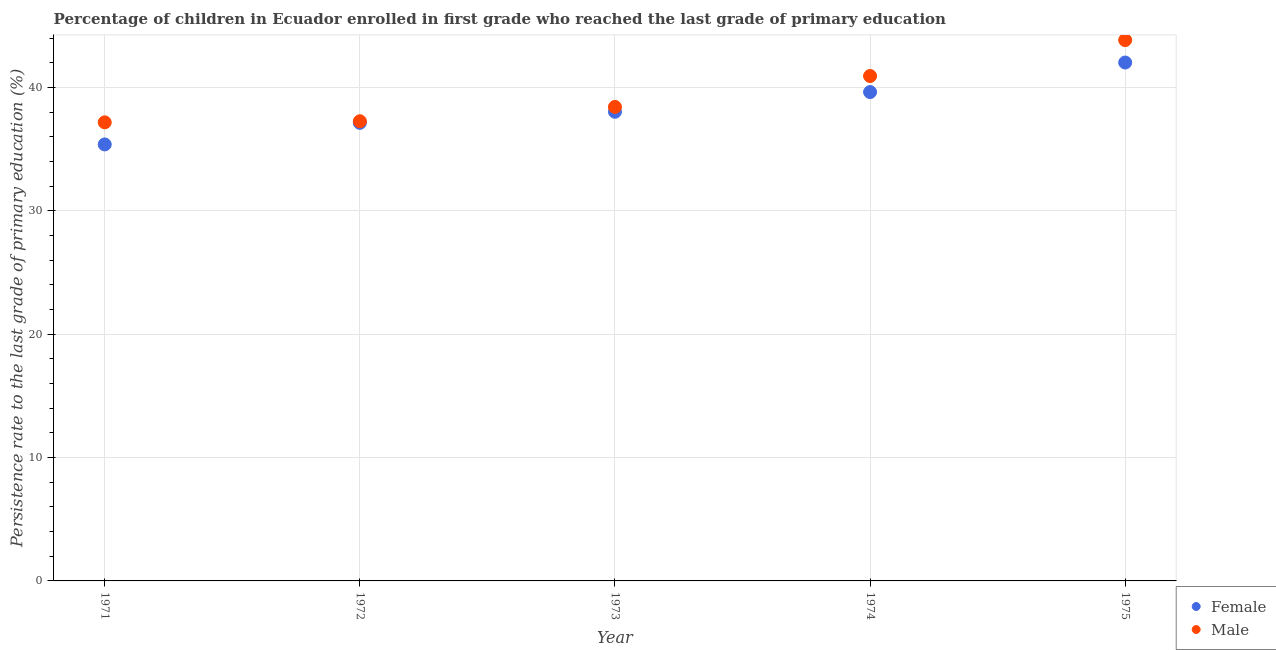Is the number of dotlines equal to the number of legend labels?
Offer a terse response. Yes. What is the persistence rate of male students in 1975?
Give a very brief answer. 43.85. Across all years, what is the maximum persistence rate of male students?
Your response must be concise. 43.85. Across all years, what is the minimum persistence rate of male students?
Ensure brevity in your answer.  37.18. In which year was the persistence rate of female students maximum?
Provide a succinct answer. 1975. In which year was the persistence rate of female students minimum?
Provide a short and direct response. 1971. What is the total persistence rate of male students in the graph?
Offer a terse response. 197.66. What is the difference between the persistence rate of female students in 1971 and that in 1975?
Your answer should be very brief. -6.64. What is the difference between the persistence rate of male students in 1974 and the persistence rate of female students in 1971?
Make the answer very short. 5.55. What is the average persistence rate of male students per year?
Provide a succinct answer. 39.53. In the year 1973, what is the difference between the persistence rate of female students and persistence rate of male students?
Offer a very short reply. -0.39. In how many years, is the persistence rate of female students greater than 28 %?
Ensure brevity in your answer.  5. What is the ratio of the persistence rate of female students in 1974 to that in 1975?
Offer a very short reply. 0.94. Is the difference between the persistence rate of male students in 1973 and 1975 greater than the difference between the persistence rate of female students in 1973 and 1975?
Make the answer very short. No. What is the difference between the highest and the second highest persistence rate of male students?
Offer a terse response. 2.91. What is the difference between the highest and the lowest persistence rate of female students?
Provide a succinct answer. 6.64. What is the difference between two consecutive major ticks on the Y-axis?
Ensure brevity in your answer.  10. Does the graph contain grids?
Offer a terse response. Yes. Where does the legend appear in the graph?
Ensure brevity in your answer.  Bottom right. How are the legend labels stacked?
Ensure brevity in your answer.  Vertical. What is the title of the graph?
Offer a very short reply. Percentage of children in Ecuador enrolled in first grade who reached the last grade of primary education. What is the label or title of the X-axis?
Ensure brevity in your answer.  Year. What is the label or title of the Y-axis?
Give a very brief answer. Persistence rate to the last grade of primary education (%). What is the Persistence rate to the last grade of primary education (%) in Female in 1971?
Keep it short and to the point. 35.39. What is the Persistence rate to the last grade of primary education (%) of Male in 1971?
Your response must be concise. 37.18. What is the Persistence rate to the last grade of primary education (%) in Female in 1972?
Make the answer very short. 37.14. What is the Persistence rate to the last grade of primary education (%) in Male in 1972?
Offer a terse response. 37.27. What is the Persistence rate to the last grade of primary education (%) in Female in 1973?
Give a very brief answer. 38.04. What is the Persistence rate to the last grade of primary education (%) in Male in 1973?
Offer a very short reply. 38.43. What is the Persistence rate to the last grade of primary education (%) of Female in 1974?
Your response must be concise. 39.63. What is the Persistence rate to the last grade of primary education (%) of Male in 1974?
Your answer should be very brief. 40.94. What is the Persistence rate to the last grade of primary education (%) of Female in 1975?
Ensure brevity in your answer.  42.03. What is the Persistence rate to the last grade of primary education (%) of Male in 1975?
Your answer should be very brief. 43.85. Across all years, what is the maximum Persistence rate to the last grade of primary education (%) of Female?
Provide a short and direct response. 42.03. Across all years, what is the maximum Persistence rate to the last grade of primary education (%) of Male?
Your answer should be compact. 43.85. Across all years, what is the minimum Persistence rate to the last grade of primary education (%) of Female?
Provide a short and direct response. 35.39. Across all years, what is the minimum Persistence rate to the last grade of primary education (%) in Male?
Ensure brevity in your answer.  37.18. What is the total Persistence rate to the last grade of primary education (%) of Female in the graph?
Provide a short and direct response. 192.23. What is the total Persistence rate to the last grade of primary education (%) of Male in the graph?
Ensure brevity in your answer.  197.66. What is the difference between the Persistence rate to the last grade of primary education (%) in Female in 1971 and that in 1972?
Provide a succinct answer. -1.75. What is the difference between the Persistence rate to the last grade of primary education (%) of Male in 1971 and that in 1972?
Keep it short and to the point. -0.09. What is the difference between the Persistence rate to the last grade of primary education (%) in Female in 1971 and that in 1973?
Offer a terse response. -2.65. What is the difference between the Persistence rate to the last grade of primary education (%) of Male in 1971 and that in 1973?
Keep it short and to the point. -1.25. What is the difference between the Persistence rate to the last grade of primary education (%) of Female in 1971 and that in 1974?
Give a very brief answer. -4.25. What is the difference between the Persistence rate to the last grade of primary education (%) in Male in 1971 and that in 1974?
Offer a very short reply. -3.76. What is the difference between the Persistence rate to the last grade of primary education (%) in Female in 1971 and that in 1975?
Your answer should be very brief. -6.64. What is the difference between the Persistence rate to the last grade of primary education (%) of Male in 1971 and that in 1975?
Give a very brief answer. -6.67. What is the difference between the Persistence rate to the last grade of primary education (%) in Female in 1972 and that in 1973?
Offer a terse response. -0.9. What is the difference between the Persistence rate to the last grade of primary education (%) of Male in 1972 and that in 1973?
Offer a terse response. -1.16. What is the difference between the Persistence rate to the last grade of primary education (%) of Female in 1972 and that in 1974?
Provide a succinct answer. -2.5. What is the difference between the Persistence rate to the last grade of primary education (%) in Male in 1972 and that in 1974?
Give a very brief answer. -3.67. What is the difference between the Persistence rate to the last grade of primary education (%) of Female in 1972 and that in 1975?
Make the answer very short. -4.89. What is the difference between the Persistence rate to the last grade of primary education (%) of Male in 1972 and that in 1975?
Keep it short and to the point. -6.58. What is the difference between the Persistence rate to the last grade of primary education (%) in Female in 1973 and that in 1974?
Give a very brief answer. -1.6. What is the difference between the Persistence rate to the last grade of primary education (%) in Male in 1973 and that in 1974?
Give a very brief answer. -2.51. What is the difference between the Persistence rate to the last grade of primary education (%) in Female in 1973 and that in 1975?
Ensure brevity in your answer.  -3.99. What is the difference between the Persistence rate to the last grade of primary education (%) in Male in 1973 and that in 1975?
Offer a terse response. -5.42. What is the difference between the Persistence rate to the last grade of primary education (%) in Female in 1974 and that in 1975?
Offer a terse response. -2.39. What is the difference between the Persistence rate to the last grade of primary education (%) in Male in 1974 and that in 1975?
Make the answer very short. -2.91. What is the difference between the Persistence rate to the last grade of primary education (%) in Female in 1971 and the Persistence rate to the last grade of primary education (%) in Male in 1972?
Your answer should be compact. -1.88. What is the difference between the Persistence rate to the last grade of primary education (%) in Female in 1971 and the Persistence rate to the last grade of primary education (%) in Male in 1973?
Give a very brief answer. -3.04. What is the difference between the Persistence rate to the last grade of primary education (%) in Female in 1971 and the Persistence rate to the last grade of primary education (%) in Male in 1974?
Make the answer very short. -5.55. What is the difference between the Persistence rate to the last grade of primary education (%) of Female in 1971 and the Persistence rate to the last grade of primary education (%) of Male in 1975?
Offer a very short reply. -8.46. What is the difference between the Persistence rate to the last grade of primary education (%) in Female in 1972 and the Persistence rate to the last grade of primary education (%) in Male in 1973?
Make the answer very short. -1.29. What is the difference between the Persistence rate to the last grade of primary education (%) of Female in 1972 and the Persistence rate to the last grade of primary education (%) of Male in 1974?
Make the answer very short. -3.8. What is the difference between the Persistence rate to the last grade of primary education (%) of Female in 1972 and the Persistence rate to the last grade of primary education (%) of Male in 1975?
Offer a terse response. -6.71. What is the difference between the Persistence rate to the last grade of primary education (%) in Female in 1973 and the Persistence rate to the last grade of primary education (%) in Male in 1974?
Your answer should be compact. -2.9. What is the difference between the Persistence rate to the last grade of primary education (%) in Female in 1973 and the Persistence rate to the last grade of primary education (%) in Male in 1975?
Offer a terse response. -5.81. What is the difference between the Persistence rate to the last grade of primary education (%) of Female in 1974 and the Persistence rate to the last grade of primary education (%) of Male in 1975?
Provide a succinct answer. -4.21. What is the average Persistence rate to the last grade of primary education (%) in Female per year?
Provide a succinct answer. 38.45. What is the average Persistence rate to the last grade of primary education (%) of Male per year?
Keep it short and to the point. 39.53. In the year 1971, what is the difference between the Persistence rate to the last grade of primary education (%) in Female and Persistence rate to the last grade of primary education (%) in Male?
Your response must be concise. -1.79. In the year 1972, what is the difference between the Persistence rate to the last grade of primary education (%) of Female and Persistence rate to the last grade of primary education (%) of Male?
Offer a terse response. -0.13. In the year 1973, what is the difference between the Persistence rate to the last grade of primary education (%) of Female and Persistence rate to the last grade of primary education (%) of Male?
Give a very brief answer. -0.39. In the year 1974, what is the difference between the Persistence rate to the last grade of primary education (%) of Female and Persistence rate to the last grade of primary education (%) of Male?
Offer a very short reply. -1.3. In the year 1975, what is the difference between the Persistence rate to the last grade of primary education (%) in Female and Persistence rate to the last grade of primary education (%) in Male?
Ensure brevity in your answer.  -1.82. What is the ratio of the Persistence rate to the last grade of primary education (%) of Female in 1971 to that in 1972?
Offer a very short reply. 0.95. What is the ratio of the Persistence rate to the last grade of primary education (%) in Female in 1971 to that in 1973?
Make the answer very short. 0.93. What is the ratio of the Persistence rate to the last grade of primary education (%) of Male in 1971 to that in 1973?
Your answer should be compact. 0.97. What is the ratio of the Persistence rate to the last grade of primary education (%) of Female in 1971 to that in 1974?
Offer a terse response. 0.89. What is the ratio of the Persistence rate to the last grade of primary education (%) in Male in 1971 to that in 1974?
Provide a succinct answer. 0.91. What is the ratio of the Persistence rate to the last grade of primary education (%) in Female in 1971 to that in 1975?
Your response must be concise. 0.84. What is the ratio of the Persistence rate to the last grade of primary education (%) of Male in 1971 to that in 1975?
Ensure brevity in your answer.  0.85. What is the ratio of the Persistence rate to the last grade of primary education (%) in Female in 1972 to that in 1973?
Give a very brief answer. 0.98. What is the ratio of the Persistence rate to the last grade of primary education (%) in Male in 1972 to that in 1973?
Your answer should be very brief. 0.97. What is the ratio of the Persistence rate to the last grade of primary education (%) of Female in 1972 to that in 1974?
Provide a succinct answer. 0.94. What is the ratio of the Persistence rate to the last grade of primary education (%) in Male in 1972 to that in 1974?
Ensure brevity in your answer.  0.91. What is the ratio of the Persistence rate to the last grade of primary education (%) in Female in 1972 to that in 1975?
Give a very brief answer. 0.88. What is the ratio of the Persistence rate to the last grade of primary education (%) of Female in 1973 to that in 1974?
Make the answer very short. 0.96. What is the ratio of the Persistence rate to the last grade of primary education (%) of Male in 1973 to that in 1974?
Give a very brief answer. 0.94. What is the ratio of the Persistence rate to the last grade of primary education (%) in Female in 1973 to that in 1975?
Keep it short and to the point. 0.91. What is the ratio of the Persistence rate to the last grade of primary education (%) in Male in 1973 to that in 1975?
Provide a short and direct response. 0.88. What is the ratio of the Persistence rate to the last grade of primary education (%) of Female in 1974 to that in 1975?
Offer a very short reply. 0.94. What is the ratio of the Persistence rate to the last grade of primary education (%) of Male in 1974 to that in 1975?
Provide a short and direct response. 0.93. What is the difference between the highest and the second highest Persistence rate to the last grade of primary education (%) in Female?
Your answer should be compact. 2.39. What is the difference between the highest and the second highest Persistence rate to the last grade of primary education (%) in Male?
Offer a terse response. 2.91. What is the difference between the highest and the lowest Persistence rate to the last grade of primary education (%) of Female?
Provide a succinct answer. 6.64. What is the difference between the highest and the lowest Persistence rate to the last grade of primary education (%) in Male?
Your answer should be compact. 6.67. 